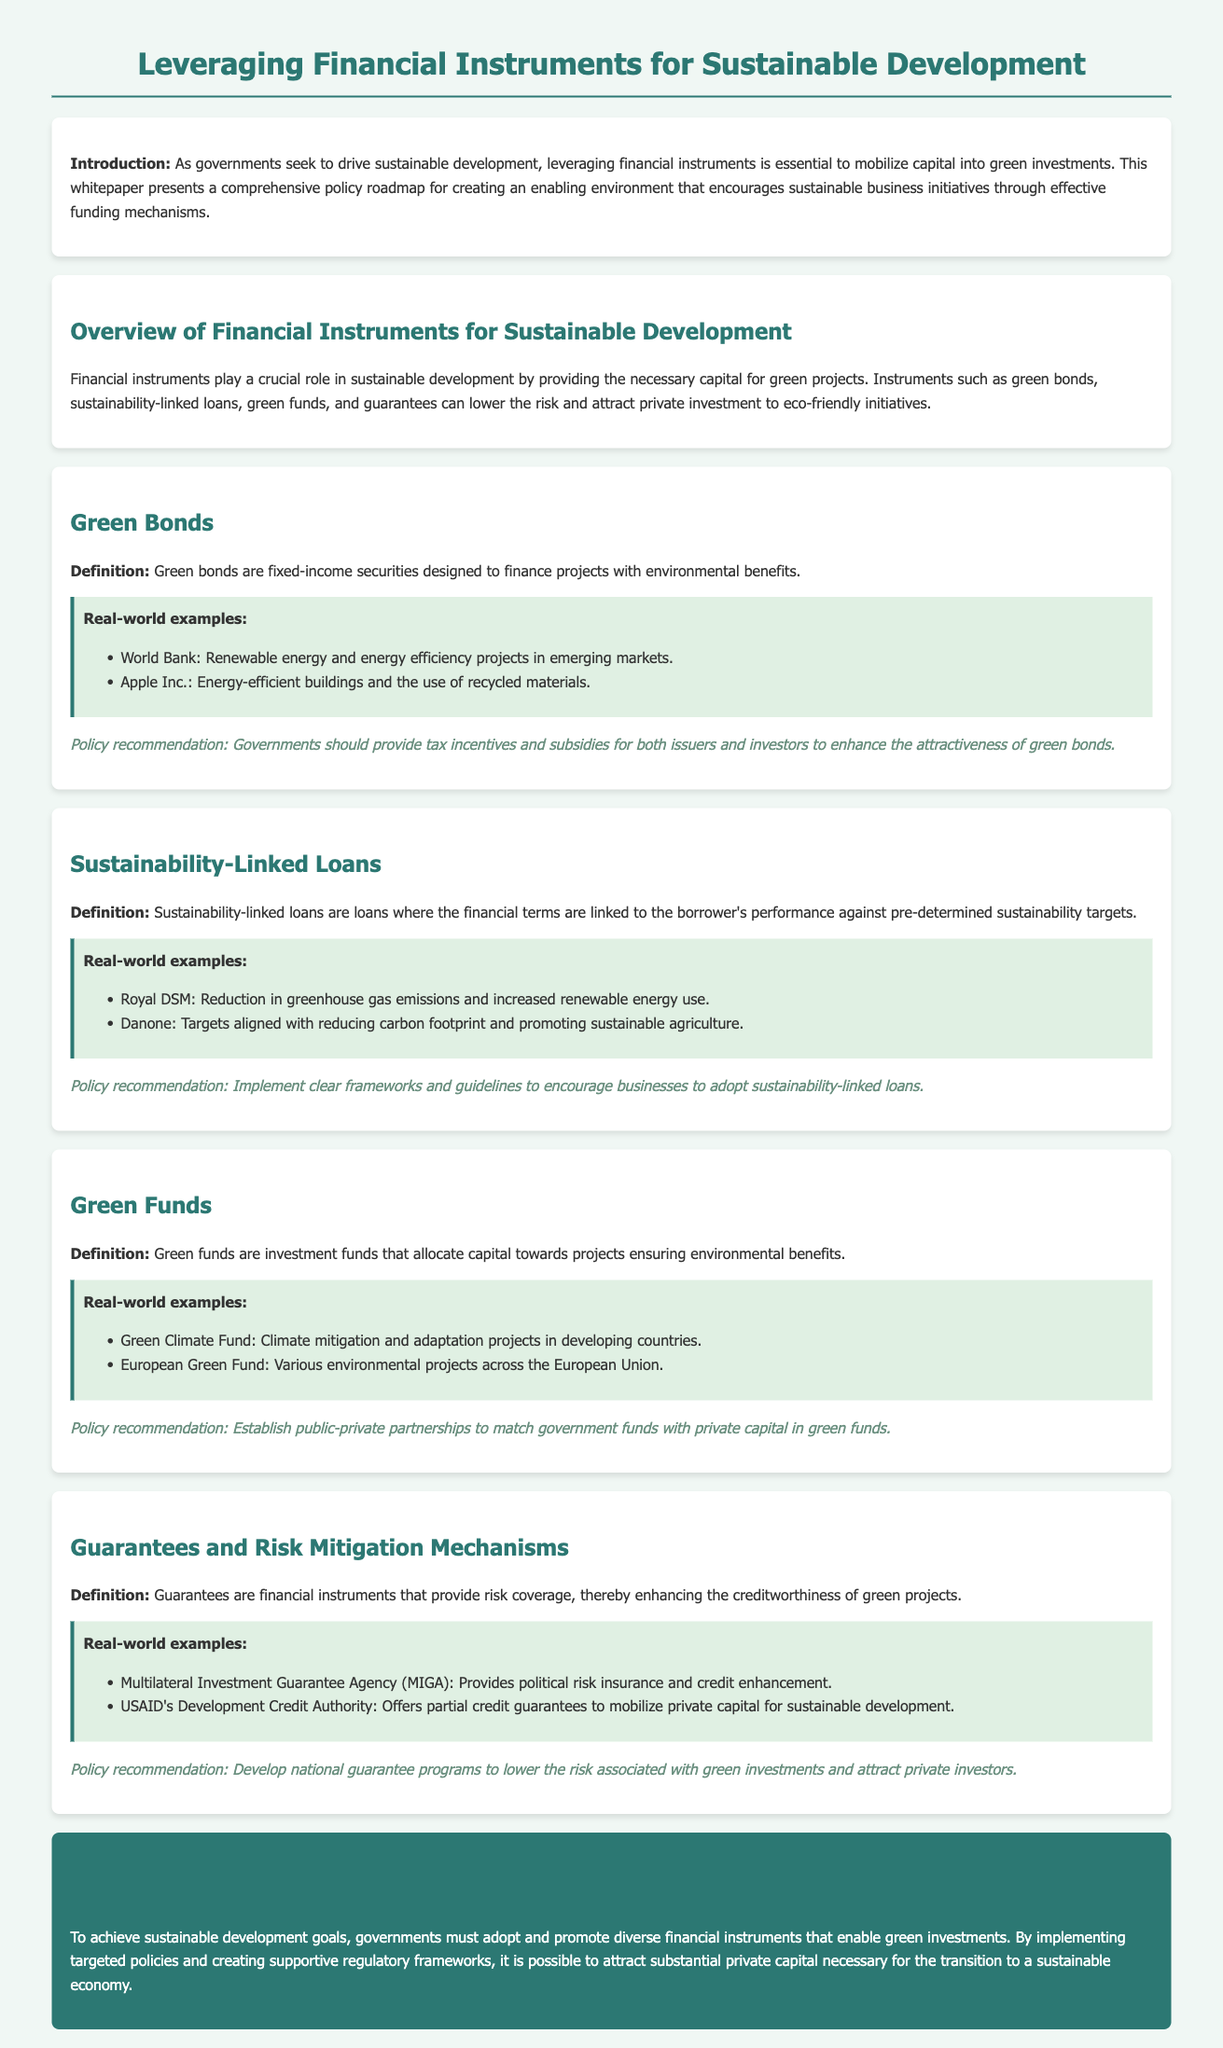What are green bonds? Green bonds are fixed-income securities designed to finance projects with environmental benefits.
Answer: Fixed-income securities designed to finance projects with environmental benefits Who issued green bonds for renewable energy projects? The document states that the World Bank issues green bonds for renewable energy and energy efficiency projects in emerging markets.
Answer: World Bank What is a key policy recommendation for green bonds? The recommendation suggests that governments should provide tax incentives and subsidies for both issuers and investors to enhance the attractiveness of green bonds.
Answer: Tax incentives and subsidies Name one real-world example of a sustainability-linked loan. The document provides examples such as Royal DSM, which focuses on reducing greenhouse gas emissions.
Answer: Royal DSM What is the role of guarantees in green investments? Guarantees provide risk coverage, thereby enhancing the creditworthiness of green projects.
Answer: Provide risk coverage What type of fund is the Green Climate Fund? The Green Climate Fund is mentioned as an investment fund that allocates capital towards climate mitigation and adaptation projects in developing countries.
Answer: Investment fund What is a recommended action for establishing green funds? The recommendation suggests establishing public-private partnerships to match government funds with private capital in green funds.
Answer: Establish public-private partnerships Which organization provides political risk insurance? The document states that the Multilateral Investment Guarantee Agency (MIGA) provides political risk insurance and credit enhancement.
Answer: Multilateral Investment Guarantee Agency (MIGA) What is the conclusion of the whitepaper? The conclusion emphasizes that governments must adopt and promote diverse financial instruments to achieve sustainable development goals.
Answer: Governments must adopt and promote diverse financial instruments 